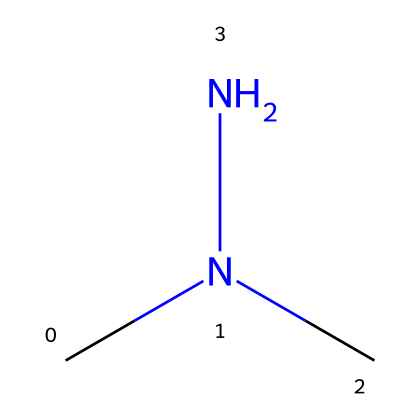What is the molecular formula of this chemical? The chemical structure indicates there are two carbon (C) atoms, six hydrogen (H) atoms, and two nitrogen (N) atoms. The molecular formula can be derived by counting the atoms present in the structure.
Answer: C2H8N2 How many nitrogen atoms are in this chemical? The structure clearly shows two nitrogen (N) atoms as part of the hydrazine group, which is characteristic of compounds in this class.
Answer: 2 What type of functional group does this chemical contain? The presence of the nitrogen-nitrogen bond (N-N) indicates that this chemical contains a hydrazine functional group, which is the defining feature of hydrazines.
Answer: hydrazine What is the primary use of 1,1-dimethylhydrazine in industrial applications? This compound is notably used as a propellant and stabilizer in rocket fuels, which shows its significance in aerospace applications, contrasting with its use in cleaning products.
Answer: rocket fuel Is this chemical considered toxic? Given the structure and the known properties of hydrazines, this chemical is recognized for being hazardous and possessing toxic effects on humans and the environment.
Answer: yes How does the number of methyl groups affect the stability of this chemical? The presence of two methyl groups (CH3-) attached to the nitrogen atoms enhances the steric hindrance, which can improve the stability of the hydrazine compound compared to those with fewer or no alkyl substituents.
Answer: increases stability 